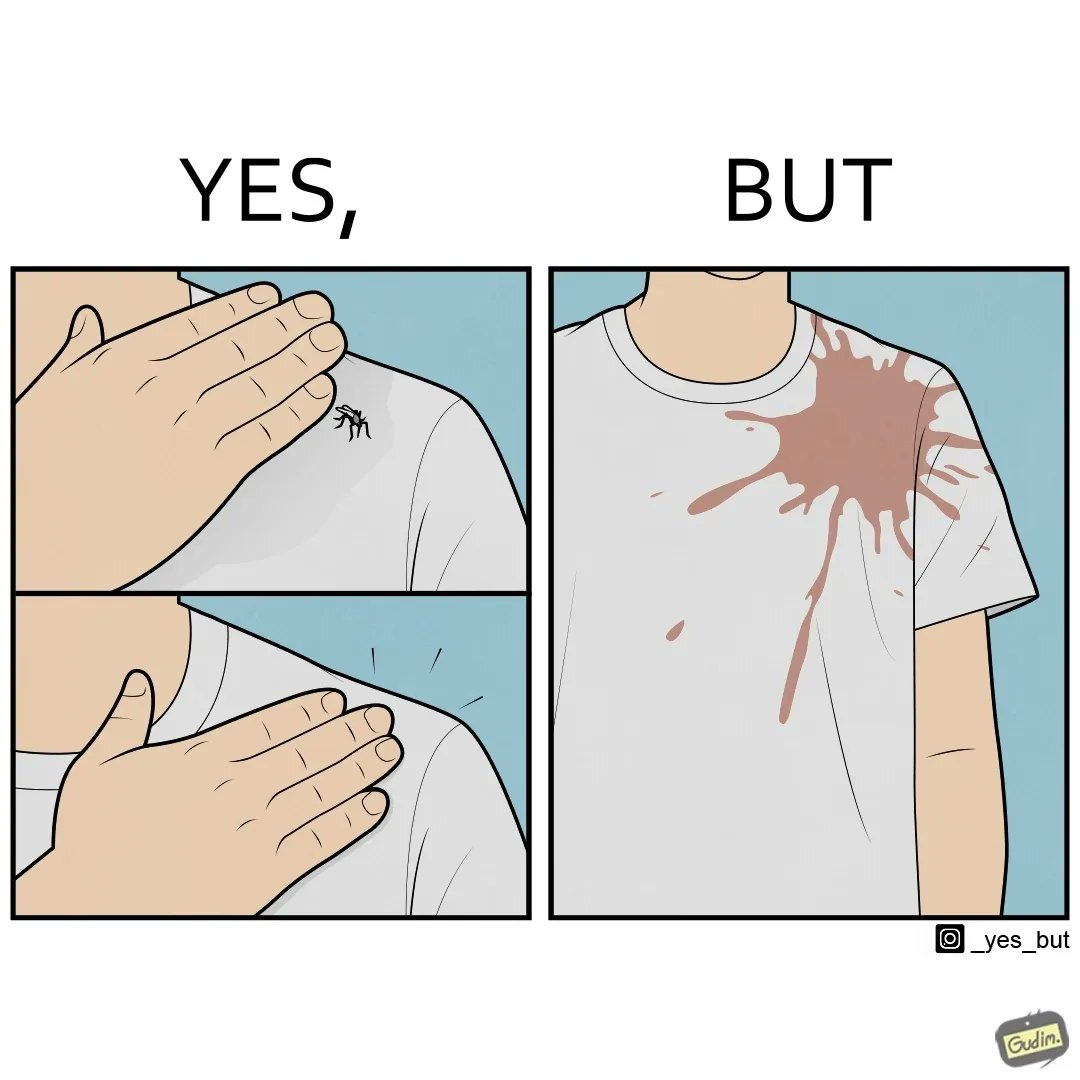What is shown in this image? The images are funny since a man trying to reduce his irritation by killing a mosquito bothering  him only causes himself more irritation by soiling his t-shirt with the mosquito blood 